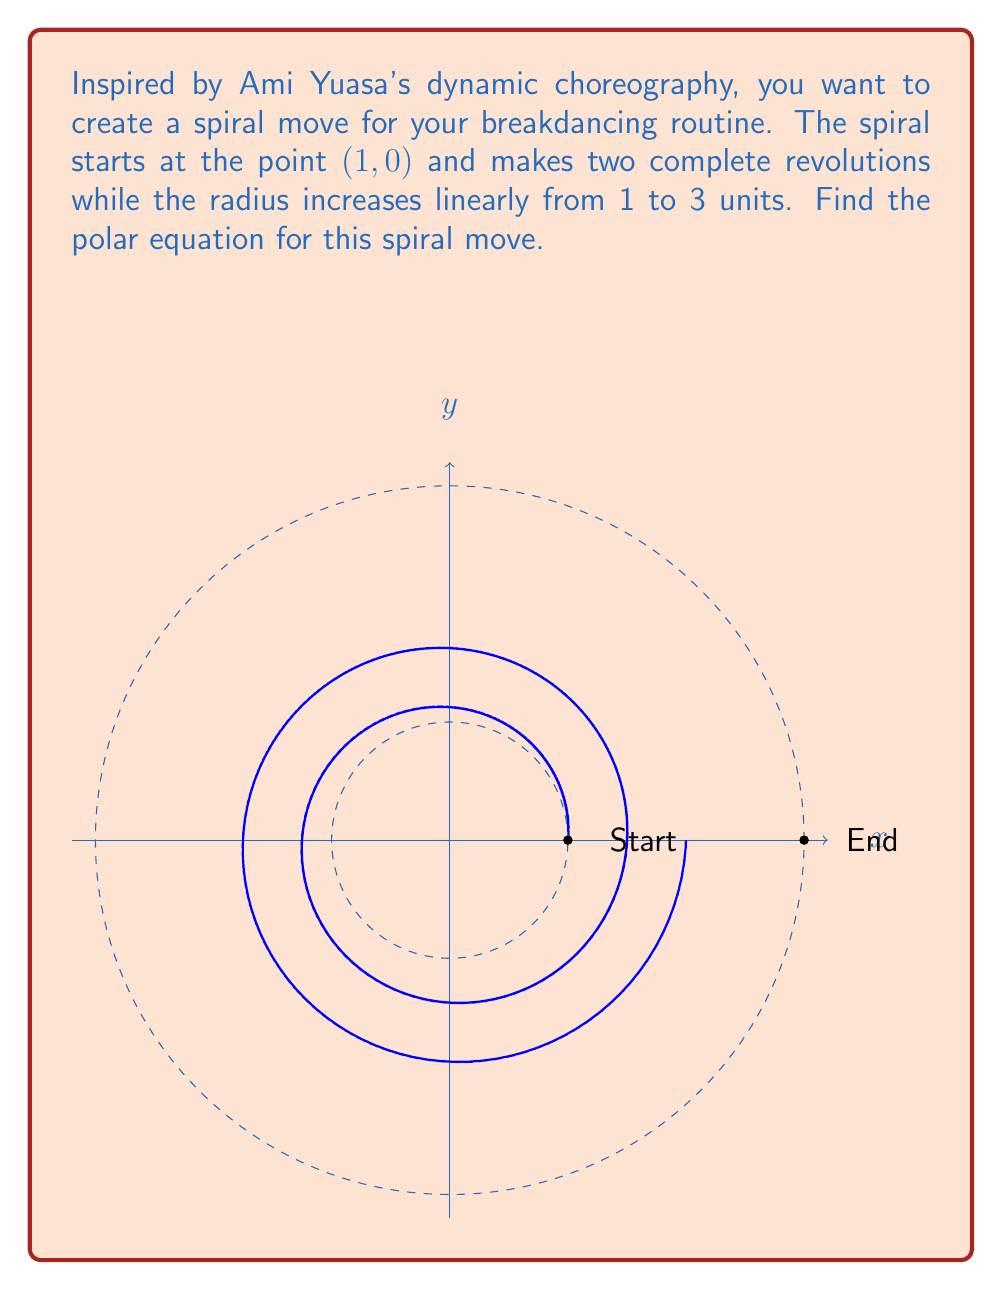Can you answer this question? Let's approach this step-by-step:

1) In polar coordinates, a spiral is generally represented by an equation of the form $r = a + b\theta$, where $a$ and $b$ are constants.

2) We know the spiral starts at (1, 0), so when $\theta = 0$, $r = 1$. This means $a = 1$.

3) The spiral makes two complete revolutions, meaning $\theta$ goes from 0 to $4\pi$ radians.

4) During these two revolutions, the radius increases from 1 to 3 units. So we need to find $b$ such that:

   $3 = 1 + b(4\pi)$

5) Solving for $b$:
   $2 = b(4\pi)$
   $b = \frac{2}{4\pi} = \frac{1}{2\pi}$

6) Therefore, our polar equation is:

   $r = 1 + \frac{\theta}{2\pi}$

This equation ensures that:
- When $\theta = 0$, $r = 1$ (start point)
- When $\theta = 4\pi$, $r = 1 + \frac{4\pi}{2\pi} = 3$ (end point)
- The radius increases linearly between these points
Answer: $r = 1 + \frac{\theta}{2\pi}$ 